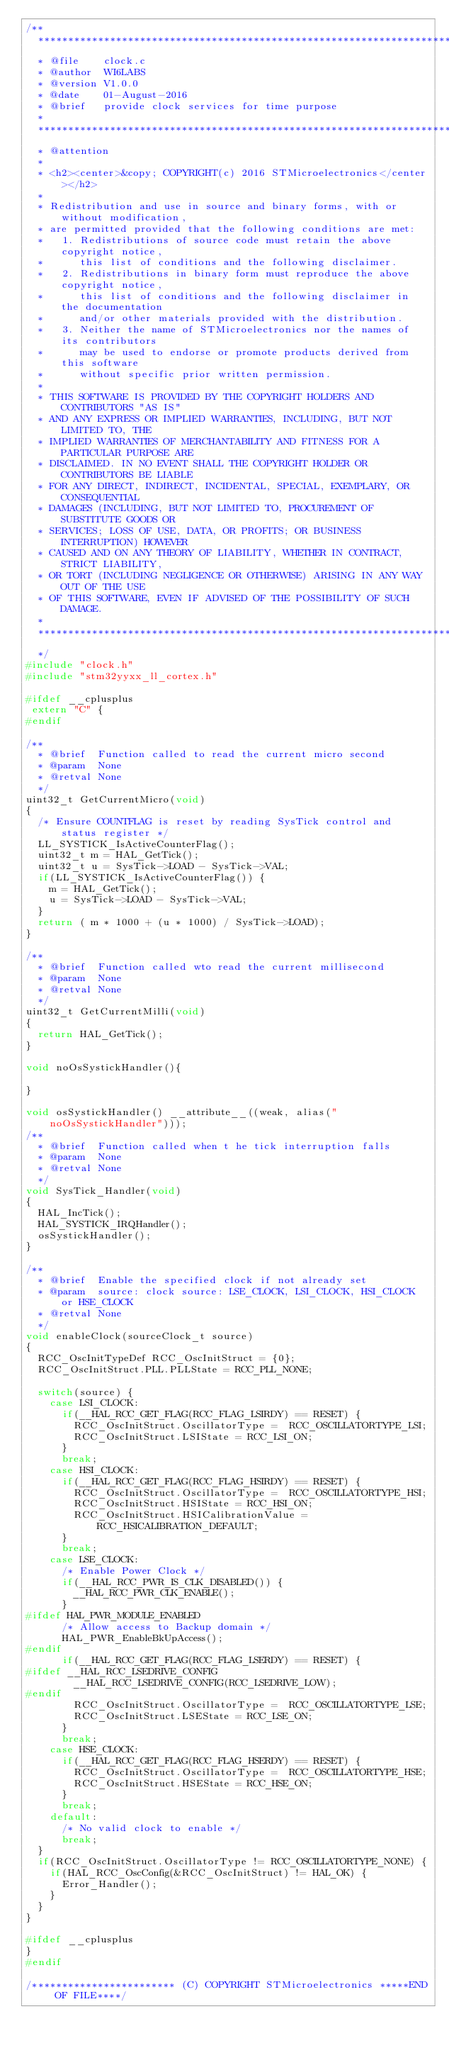<code> <loc_0><loc_0><loc_500><loc_500><_C_>/**
  ******************************************************************************
  * @file    clock.c
  * @author  WI6LABS
  * @version V1.0.0
  * @date    01-August-2016
  * @brief   provide clock services for time purpose
  *
  ******************************************************************************
  * @attention
  *
  * <h2><center>&copy; COPYRIGHT(c) 2016 STMicroelectronics</center></h2>
  *
  * Redistribution and use in source and binary forms, with or without modification,
  * are permitted provided that the following conditions are met:
  *   1. Redistributions of source code must retain the above copyright notice,
  *      this list of conditions and the following disclaimer.
  *   2. Redistributions in binary form must reproduce the above copyright notice,
  *      this list of conditions and the following disclaimer in the documentation
  *      and/or other materials provided with the distribution.
  *   3. Neither the name of STMicroelectronics nor the names of its contributors
  *      may be used to endorse or promote products derived from this software
  *      without specific prior written permission.
  *
  * THIS SOFTWARE IS PROVIDED BY THE COPYRIGHT HOLDERS AND CONTRIBUTORS "AS IS"
  * AND ANY EXPRESS OR IMPLIED WARRANTIES, INCLUDING, BUT NOT LIMITED TO, THE
  * IMPLIED WARRANTIES OF MERCHANTABILITY AND FITNESS FOR A PARTICULAR PURPOSE ARE
  * DISCLAIMED. IN NO EVENT SHALL THE COPYRIGHT HOLDER OR CONTRIBUTORS BE LIABLE
  * FOR ANY DIRECT, INDIRECT, INCIDENTAL, SPECIAL, EXEMPLARY, OR CONSEQUENTIAL
  * DAMAGES (INCLUDING, BUT NOT LIMITED TO, PROCUREMENT OF SUBSTITUTE GOODS OR
  * SERVICES; LOSS OF USE, DATA, OR PROFITS; OR BUSINESS INTERRUPTION) HOWEVER
  * CAUSED AND ON ANY THEORY OF LIABILITY, WHETHER IN CONTRACT, STRICT LIABILITY,
  * OR TORT (INCLUDING NEGLIGENCE OR OTHERWISE) ARISING IN ANY WAY OUT OF THE USE
  * OF THIS SOFTWARE, EVEN IF ADVISED OF THE POSSIBILITY OF SUCH DAMAGE.
  *
  ******************************************************************************
  */
#include "clock.h"
#include "stm32yyxx_ll_cortex.h"

#ifdef __cplusplus
 extern "C" {
#endif

/**
  * @brief  Function called to read the current micro second
  * @param  None
  * @retval None
  */
uint32_t GetCurrentMicro(void)
{
  /* Ensure COUNTFLAG is reset by reading SysTick control and status register */
  LL_SYSTICK_IsActiveCounterFlag();
  uint32_t m = HAL_GetTick();
  uint32_t u = SysTick->LOAD - SysTick->VAL;
  if(LL_SYSTICK_IsActiveCounterFlag()) {
    m = HAL_GetTick();
    u = SysTick->LOAD - SysTick->VAL;
  }
  return ( m * 1000 + (u * 1000) / SysTick->LOAD);
}

/**
  * @brief  Function called wto read the current millisecond
  * @param  None
  * @retval None
  */
uint32_t GetCurrentMilli(void)
{
  return HAL_GetTick();
}

void noOsSystickHandler(){

}

void osSystickHandler() __attribute__((weak, alias("noOsSystickHandler")));
/**
  * @brief  Function called when t he tick interruption falls
  * @param  None
  * @retval None
  */
void SysTick_Handler(void)
{
  HAL_IncTick();
  HAL_SYSTICK_IRQHandler();
  osSystickHandler();
}

/**
  * @brief  Enable the specified clock if not already set
  * @param  source: clock source: LSE_CLOCK, LSI_CLOCK, HSI_CLOCK or HSE_CLOCK
  * @retval None
  */
void enableClock(sourceClock_t source)
{
  RCC_OscInitTypeDef RCC_OscInitStruct = {0};
  RCC_OscInitStruct.PLL.PLLState = RCC_PLL_NONE;

  switch(source) {
    case LSI_CLOCK:
      if(__HAL_RCC_GET_FLAG(RCC_FLAG_LSIRDY) == RESET) {
        RCC_OscInitStruct.OscillatorType =  RCC_OSCILLATORTYPE_LSI;
        RCC_OscInitStruct.LSIState = RCC_LSI_ON;
      }
      break;
    case HSI_CLOCK:
      if(__HAL_RCC_GET_FLAG(RCC_FLAG_HSIRDY) == RESET) {
        RCC_OscInitStruct.OscillatorType =  RCC_OSCILLATORTYPE_HSI;
        RCC_OscInitStruct.HSIState = RCC_HSI_ON;
        RCC_OscInitStruct.HSICalibrationValue = RCC_HSICALIBRATION_DEFAULT;
      }
      break;
    case LSE_CLOCK:
      /* Enable Power Clock */
      if(__HAL_RCC_PWR_IS_CLK_DISABLED()) {
        __HAL_RCC_PWR_CLK_ENABLE();
      }
#ifdef HAL_PWR_MODULE_ENABLED
      /* Allow access to Backup domain */
      HAL_PWR_EnableBkUpAccess();
#endif
      if(__HAL_RCC_GET_FLAG(RCC_FLAG_LSERDY) == RESET) {
#ifdef __HAL_RCC_LSEDRIVE_CONFIG
        __HAL_RCC_LSEDRIVE_CONFIG(RCC_LSEDRIVE_LOW);
#endif
        RCC_OscInitStruct.OscillatorType =  RCC_OSCILLATORTYPE_LSE;
        RCC_OscInitStruct.LSEState = RCC_LSE_ON;
      }
      break;
    case HSE_CLOCK:
      if(__HAL_RCC_GET_FLAG(RCC_FLAG_HSERDY) == RESET) {
        RCC_OscInitStruct.OscillatorType =  RCC_OSCILLATORTYPE_HSE;
        RCC_OscInitStruct.HSEState = RCC_HSE_ON;
      }
      break;
    default:
      /* No valid clock to enable */
      break;
  }
  if(RCC_OscInitStruct.OscillatorType != RCC_OSCILLATORTYPE_NONE) {
    if(HAL_RCC_OscConfig(&RCC_OscInitStruct) != HAL_OK) {
      Error_Handler();
    }
  }
}

#ifdef __cplusplus
}
#endif

/************************ (C) COPYRIGHT STMicroelectronics *****END OF FILE****/
</code> 